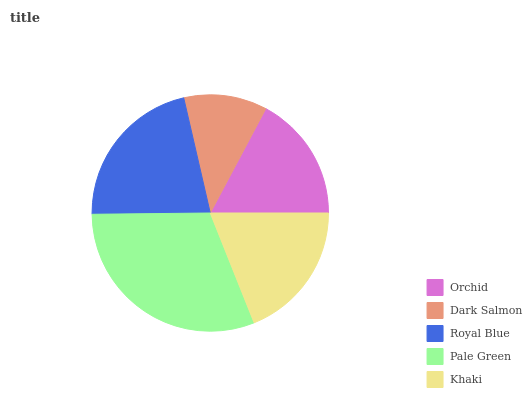Is Dark Salmon the minimum?
Answer yes or no. Yes. Is Pale Green the maximum?
Answer yes or no. Yes. Is Royal Blue the minimum?
Answer yes or no. No. Is Royal Blue the maximum?
Answer yes or no. No. Is Royal Blue greater than Dark Salmon?
Answer yes or no. Yes. Is Dark Salmon less than Royal Blue?
Answer yes or no. Yes. Is Dark Salmon greater than Royal Blue?
Answer yes or no. No. Is Royal Blue less than Dark Salmon?
Answer yes or no. No. Is Khaki the high median?
Answer yes or no. Yes. Is Khaki the low median?
Answer yes or no. Yes. Is Royal Blue the high median?
Answer yes or no. No. Is Royal Blue the low median?
Answer yes or no. No. 